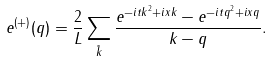<formula> <loc_0><loc_0><loc_500><loc_500>e ^ { ( + ) } ( q ) = \frac { 2 } { L } \sum _ { \tilde { k } } \frac { e ^ { - i t k ^ { 2 } + i x k } - e ^ { - i t q ^ { 2 } + i x q } } { k - q } .</formula> 